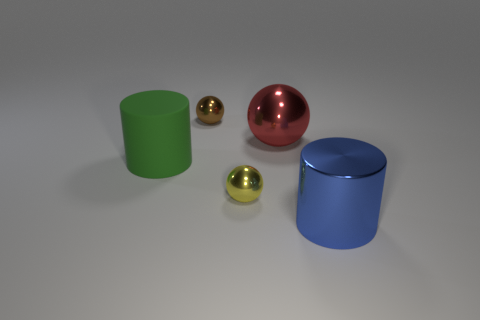There is a tiny ball that is to the left of the small shiny thing that is in front of the cylinder behind the large blue thing; what is its material?
Ensure brevity in your answer.  Metal. Are there more balls behind the big green rubber object than brown objects that are in front of the big sphere?
Offer a very short reply. Yes. Do the red shiny sphere and the blue shiny thing have the same size?
Provide a succinct answer. Yes. The other big thing that is the same shape as the yellow metallic thing is what color?
Your answer should be compact. Red. How many large objects are the same color as the metallic cylinder?
Provide a short and direct response. 0. Are there more blue metallic things that are right of the blue cylinder than metal cylinders?
Your answer should be compact. No. What is the color of the object on the left side of the tiny shiny ball that is behind the green matte cylinder?
Your answer should be compact. Green. How many objects are either red objects that are behind the tiny yellow metallic sphere or shiny objects that are to the left of the big blue thing?
Give a very brief answer. 3. What is the color of the big metal cylinder?
Give a very brief answer. Blue. How many small brown spheres have the same material as the large red object?
Provide a short and direct response. 1. 